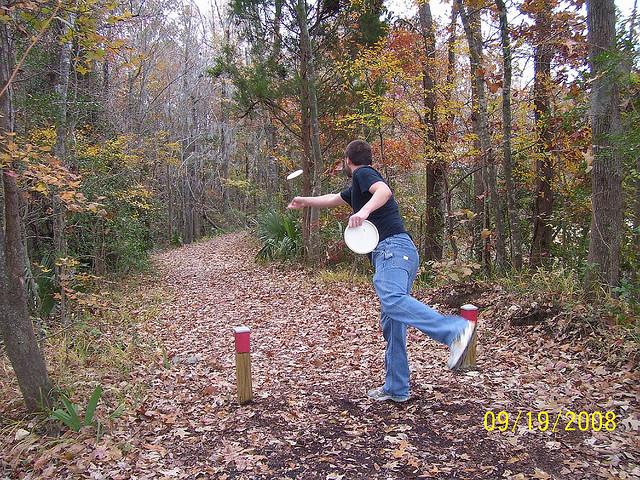Who is he throwing to?
Answer briefly. No one. When was this picture taken?
Answer briefly. 09/19/2008. What season is it?
Quick response, please. Fall. What color is the man's shirt?
Quick response, please. Black. What are the white circular objects in the photo?
Write a very short answer. Frisbee. Is it spring or Autumn?
Concise answer only. Autumn. Did he make the shot?
Be succinct. No. 